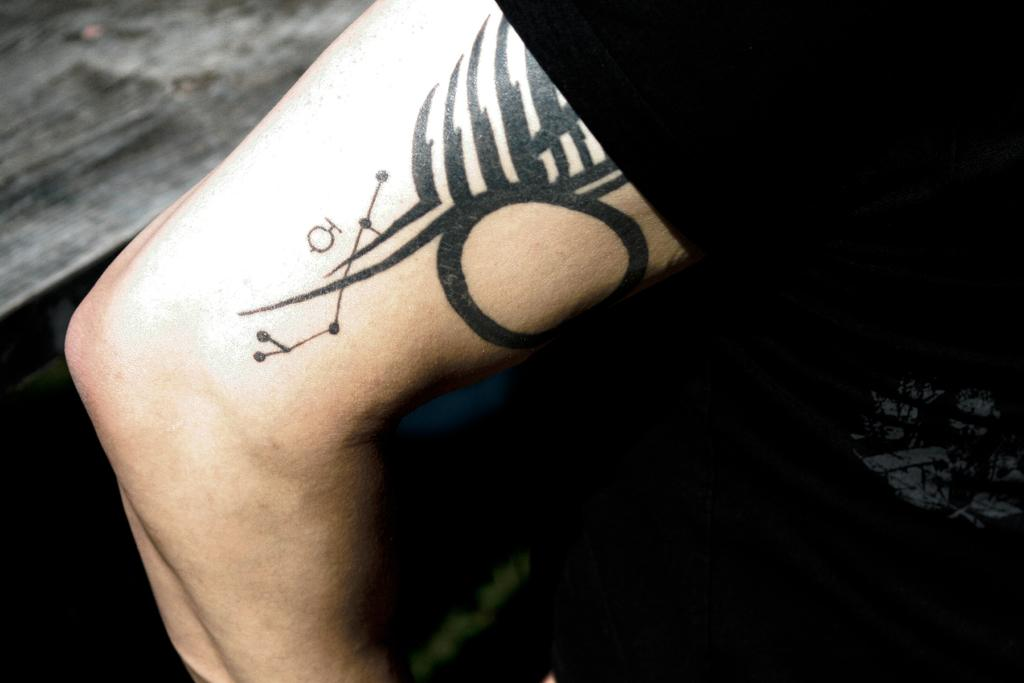What is present on the hand of the person in the image? There is a tattoo on the hand of a person in the image. What color is the door in the image? There is no door present in the image; it only features a tattoo on the hand of a person. 